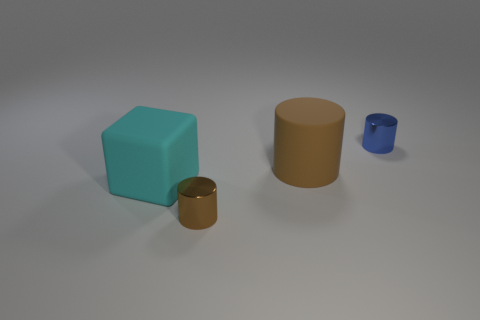There is a large cube that is in front of the tiny object behind the metal cylinder in front of the blue cylinder; what is its color?
Your answer should be compact. Cyan. Is the size of the rubber block the same as the blue cylinder?
Provide a short and direct response. No. How many cylinders are the same size as the cyan thing?
Offer a terse response. 1. Does the brown thing behind the big cyan cube have the same material as the brown cylinder in front of the big cyan rubber thing?
Make the answer very short. No. Is there any other thing that has the same shape as the large brown rubber object?
Give a very brief answer. Yes. What is the color of the big matte block?
Keep it short and to the point. Cyan. What number of other big things are the same shape as the blue object?
Provide a short and direct response. 1. There is a thing that is the same size as the brown matte cylinder; what color is it?
Your answer should be very brief. Cyan. Are there any large cyan matte blocks?
Ensure brevity in your answer.  Yes. What shape is the large object in front of the matte cylinder?
Your answer should be very brief. Cube. 